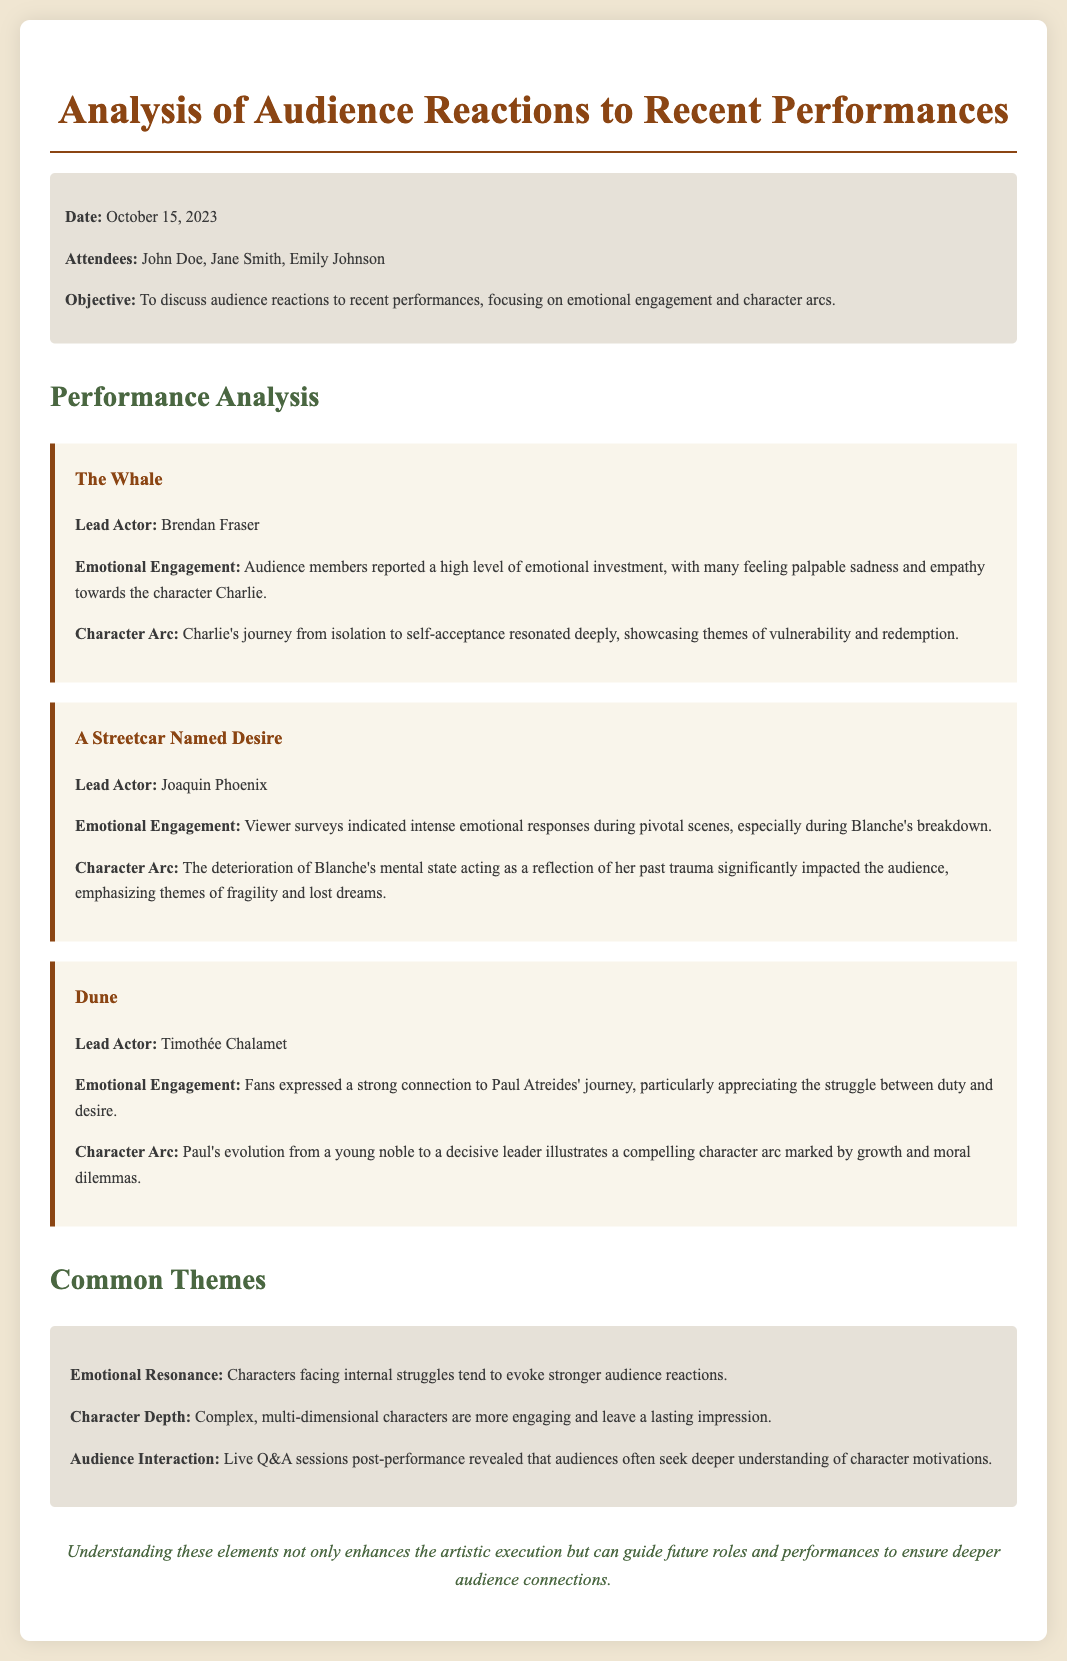What is the date of the meeting? The date of the meeting is stated in the meta-info section of the document.
Answer: October 15, 2023 Who reported high emotional engagement in "The Whale"? The lead actor of "The Whale" is mentioned, and audience reactions are discussed.
Answer: Brendan Fraser What theme is reflected in Blanche's character arc in "A Streetcar Named Desire"? The character arc of Blanche is detailed, including the impact of her past.
Answer: Past trauma What was the audience's connection to Paul Atreides in "Dune"? The document highlights audience sentiments about Paul Atreides' journey.
Answer: Strong connection What common theme is seen in characters facing internal struggles? The document discusses how certain character qualities affect audience reactions.
Answer: Stronger audience reactions What type of characters are described as more engaging? Analysis of character types is provided in the common themes section.
Answer: Complex, multi-dimensional characters 